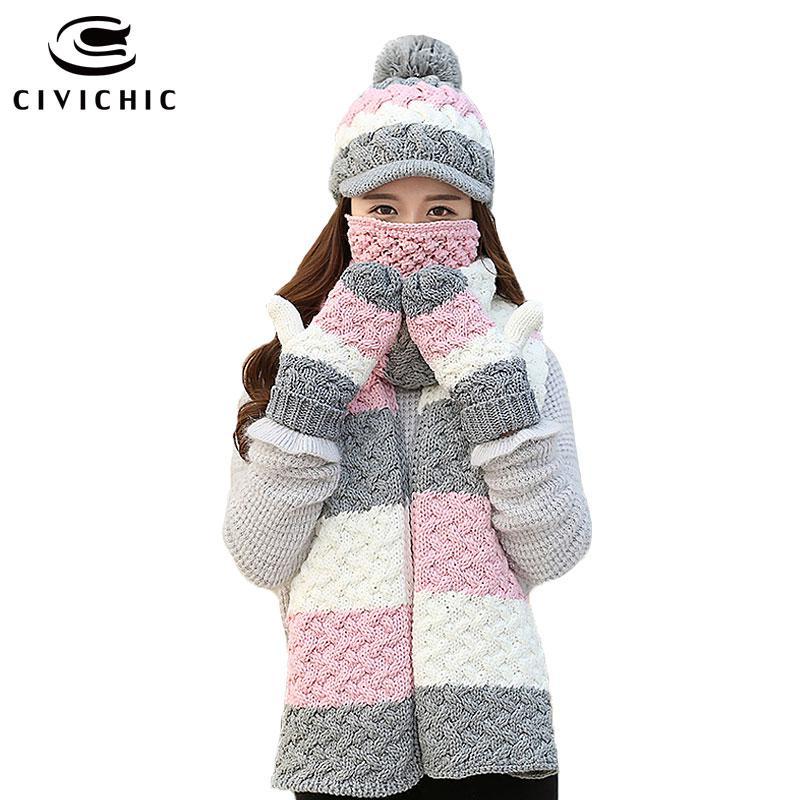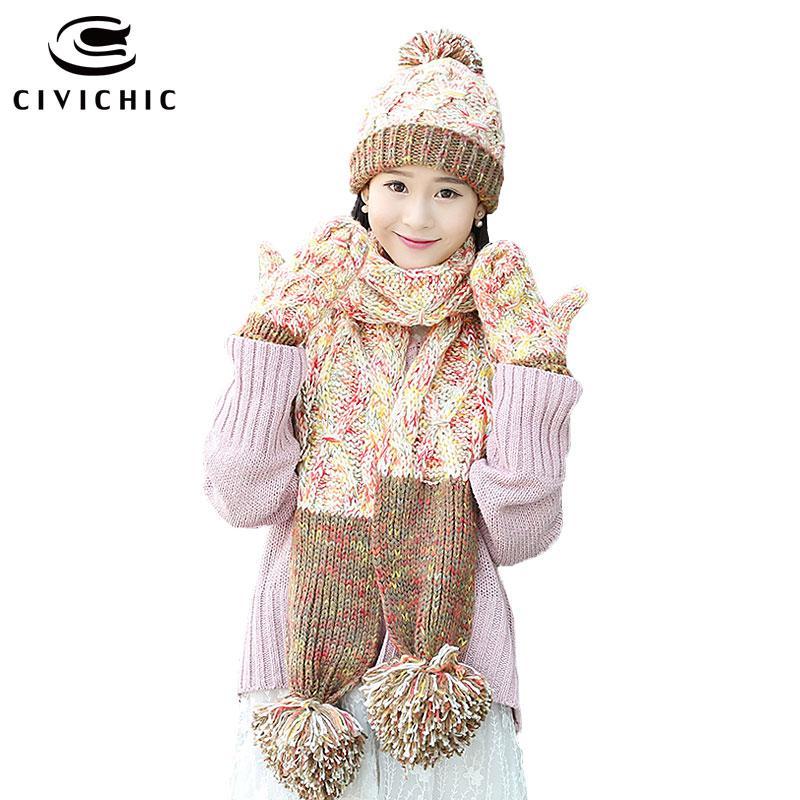The first image is the image on the left, the second image is the image on the right. Given the left and right images, does the statement "There is a girl with her mouth covered." hold true? Answer yes or no. Yes. 